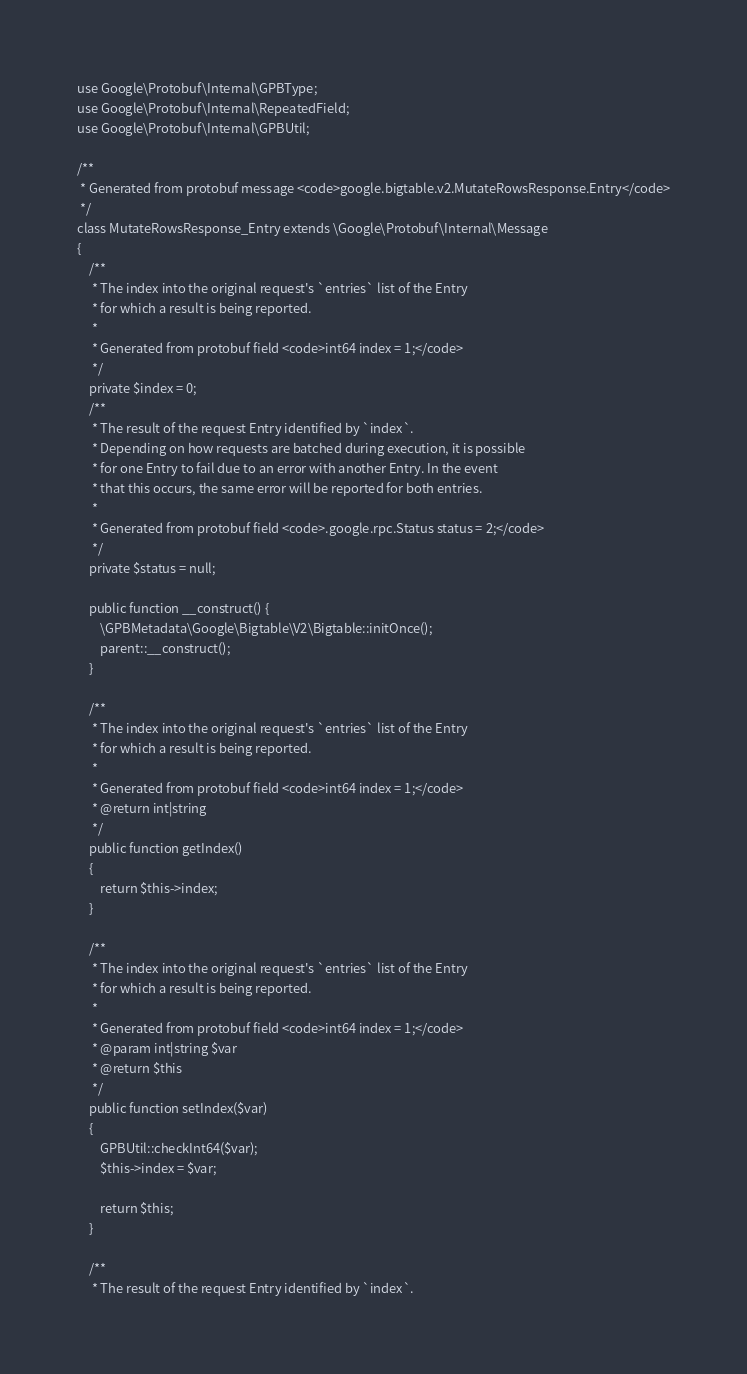Convert code to text. <code><loc_0><loc_0><loc_500><loc_500><_PHP_>use Google\Protobuf\Internal\GPBType;
use Google\Protobuf\Internal\RepeatedField;
use Google\Protobuf\Internal\GPBUtil;

/**
 * Generated from protobuf message <code>google.bigtable.v2.MutateRowsResponse.Entry</code>
 */
class MutateRowsResponse_Entry extends \Google\Protobuf\Internal\Message
{
    /**
     * The index into the original request's `entries` list of the Entry
     * for which a result is being reported.
     *
     * Generated from protobuf field <code>int64 index = 1;</code>
     */
    private $index = 0;
    /**
     * The result of the request Entry identified by `index`.
     * Depending on how requests are batched during execution, it is possible
     * for one Entry to fail due to an error with another Entry. In the event
     * that this occurs, the same error will be reported for both entries.
     *
     * Generated from protobuf field <code>.google.rpc.Status status = 2;</code>
     */
    private $status = null;

    public function __construct() {
        \GPBMetadata\Google\Bigtable\V2\Bigtable::initOnce();
        parent::__construct();
    }

    /**
     * The index into the original request's `entries` list of the Entry
     * for which a result is being reported.
     *
     * Generated from protobuf field <code>int64 index = 1;</code>
     * @return int|string
     */
    public function getIndex()
    {
        return $this->index;
    }

    /**
     * The index into the original request's `entries` list of the Entry
     * for which a result is being reported.
     *
     * Generated from protobuf field <code>int64 index = 1;</code>
     * @param int|string $var
     * @return $this
     */
    public function setIndex($var)
    {
        GPBUtil::checkInt64($var);
        $this->index = $var;

        return $this;
    }

    /**
     * The result of the request Entry identified by `index`.</code> 